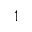Convert formula to latex. <formula><loc_0><loc_0><loc_500><loc_500>1</formula> 